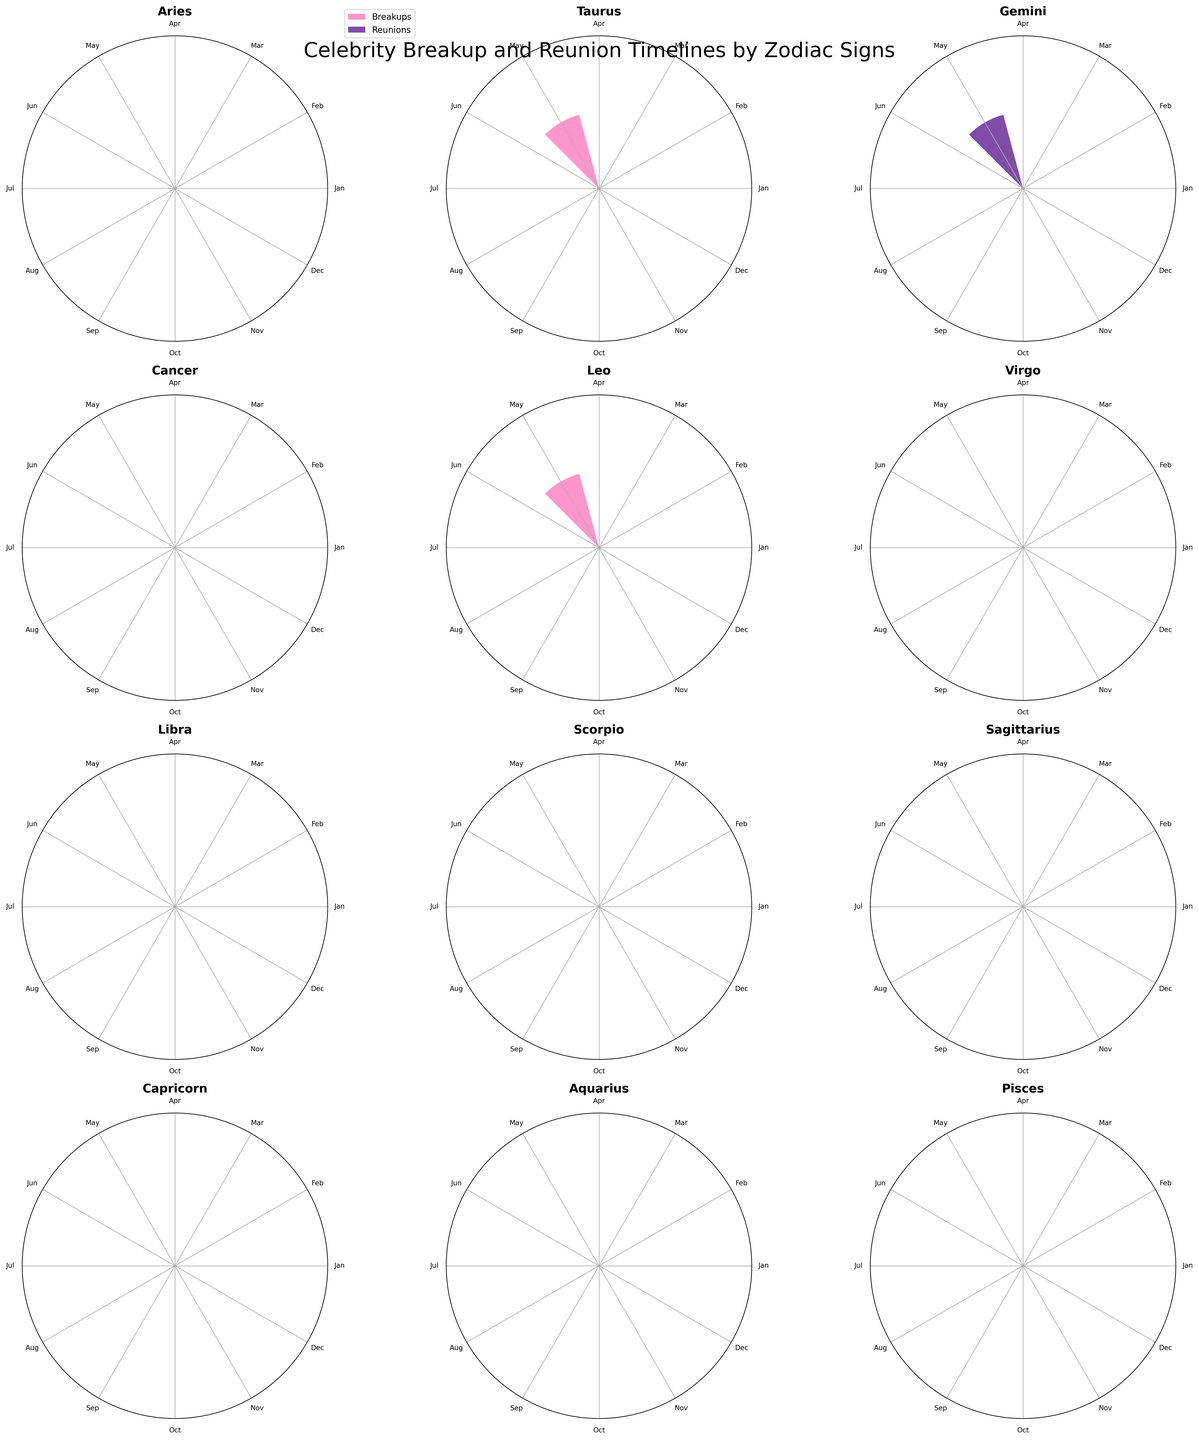Which zodiac sign has the most breakups in January? Looking at the chart, we identify the bars representing breakups in January for each zodiac sign. Capricorn and Pisces each have breakups in January.
Answer: Capricorn and Pisces Which month has the highest number of celebrity reunions for Leo? Observing Leo's subplot, we find the bar with the highest value for reunions.
Answer: June How many breakups and reunions happened for Taurus? Summing up the counts for breakup and reunion bars in Taurus's subplot, we find one breakup (May) and one reunion (August).
Answer: 2 Which zodiac sign has the lowest number of breakup events overall in the chart? Each zodiac sign's subplot shows breakup events. Comparing these, Sagittarius only has one breakup event.
Answer: Sagittarius Do Gemini and Virgo have more breakups or reunions combined for June? Reviewing Gemini and Virgo subplots for June, we see that neither has breakups or reunions in that month.
Answer: None Which zodiac sign shows a reunion in February? By checking all subplots, we find that Virgo has a reunion in February.
Answer: Virgo In which month do Scorpio’s breakups occur? We look at Scorpio's subplot and identify that the breakup bar appears in December.
Answer: December How many total reunions are represented for Sagittarius in the figure? Only one reunion bar is shown in Sagittarius's subplot.
Answer: 1 Which celebrity couple broke up in March under the Aquarius zodiac sign? Referring to Aquarius's subplot, Emma Roberts & Evan Peters broke up in March.
Answer: Emma Roberts & Evan Peters 